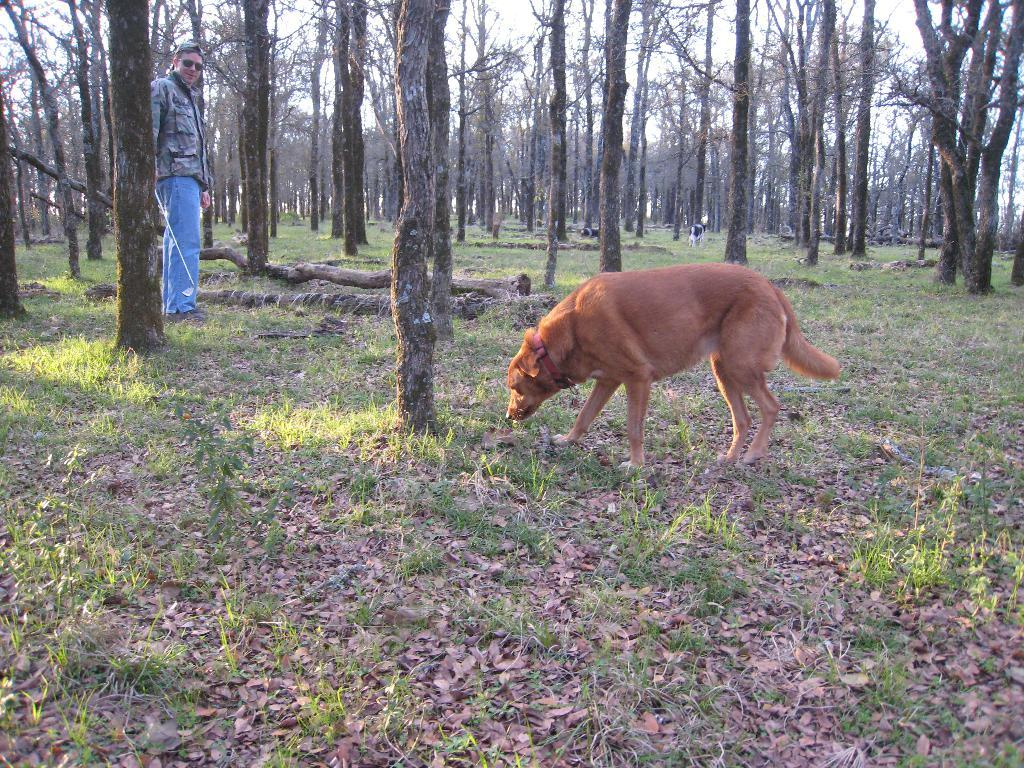What animal is on the right side of the image? There is a dog on the right side of the image. What is the color of the dog? The dog is brown in color. What type of vegetation is present in the image? There are trees in the image. What is the man on the left side of the image wearing? The man is wearing a coat and trousers. What type of tin structure can be seen in the image? There is no tin structure present in the image. What type of beam is supporting the trees in the image? There is no beam present in the image; the trees are standing on their own. 